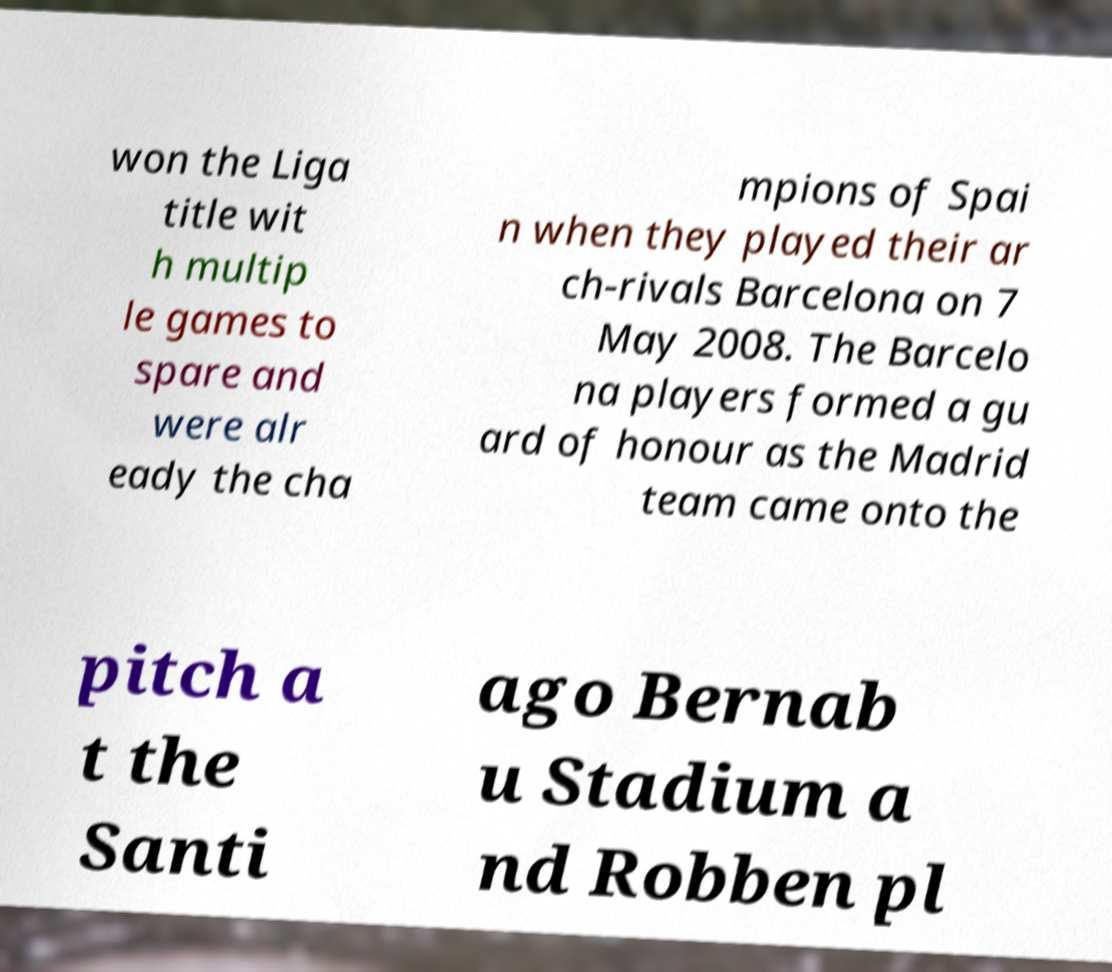Can you read and provide the text displayed in the image?This photo seems to have some interesting text. Can you extract and type it out for me? won the Liga title wit h multip le games to spare and were alr eady the cha mpions of Spai n when they played their ar ch-rivals Barcelona on 7 May 2008. The Barcelo na players formed a gu ard of honour as the Madrid team came onto the pitch a t the Santi ago Bernab u Stadium a nd Robben pl 